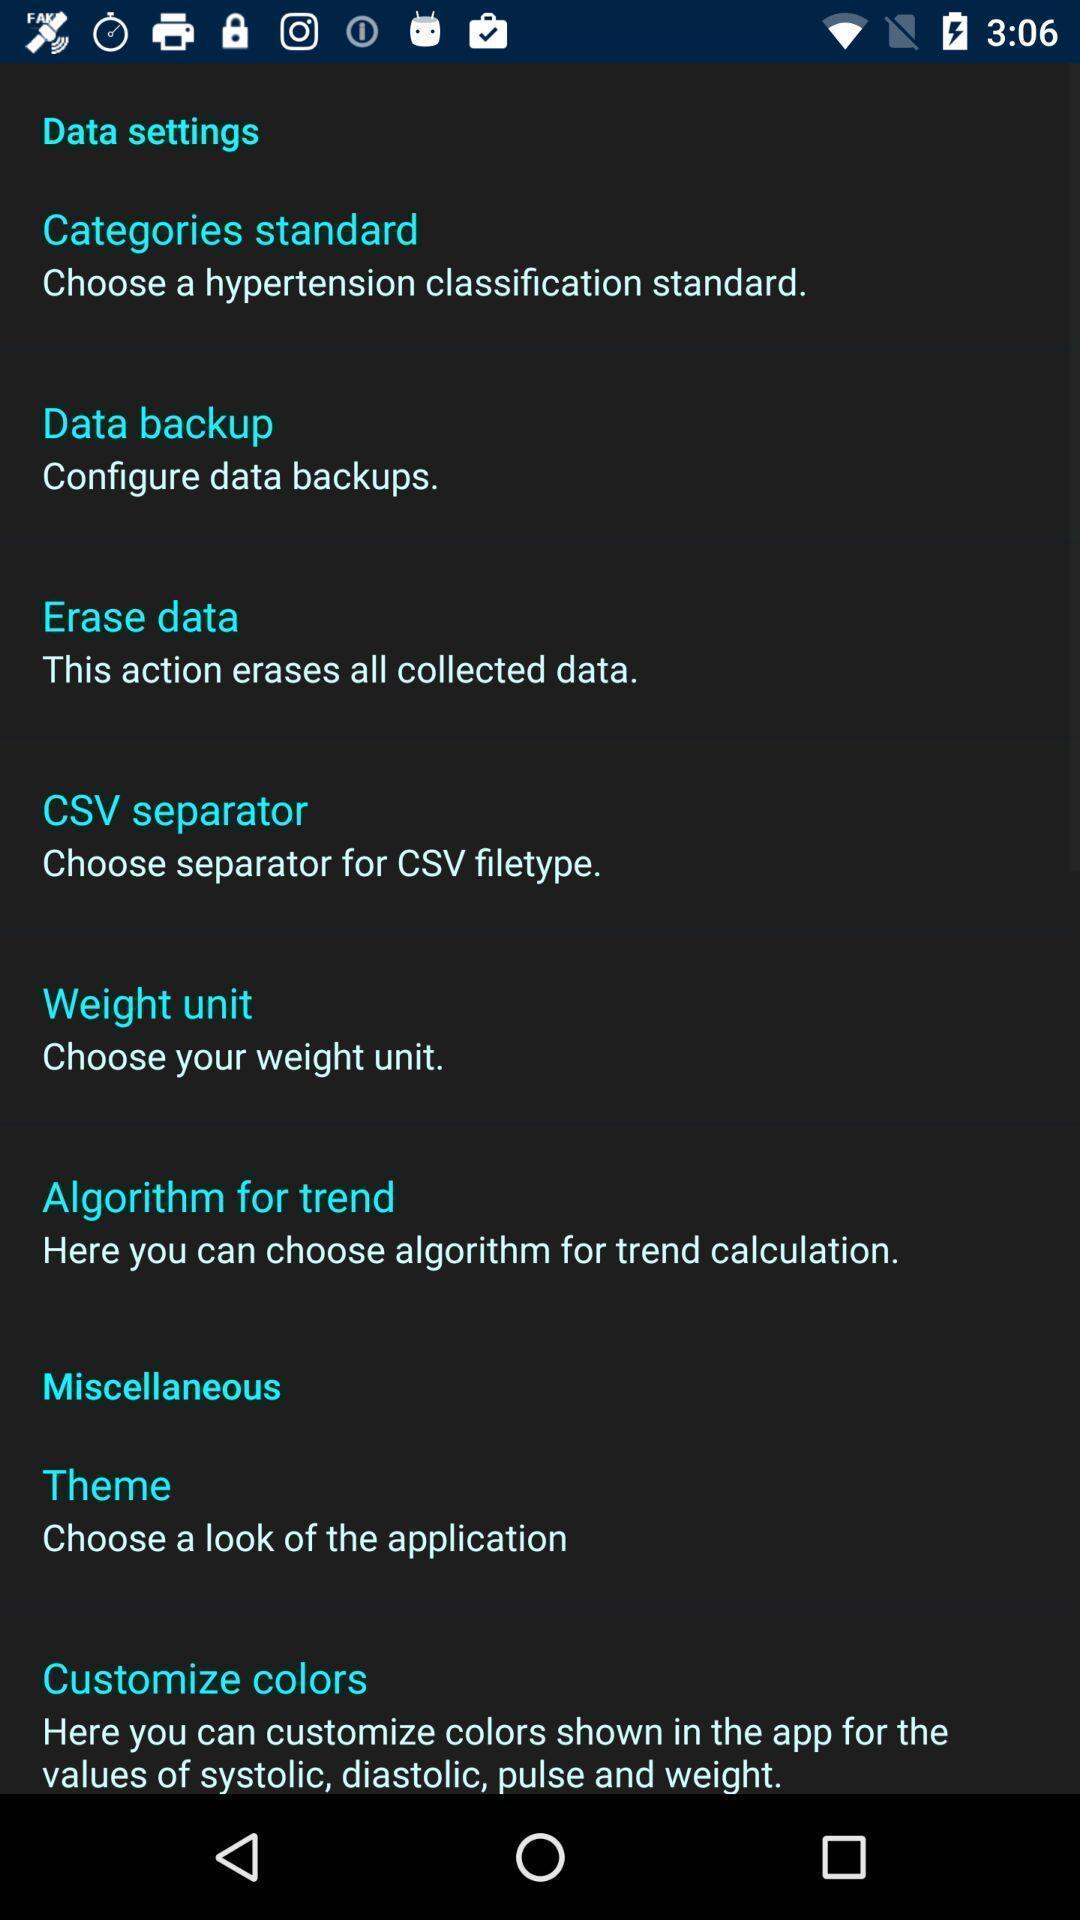Describe the key features of this screenshot. Page displaying multiple data setting and miscellaneous options. 